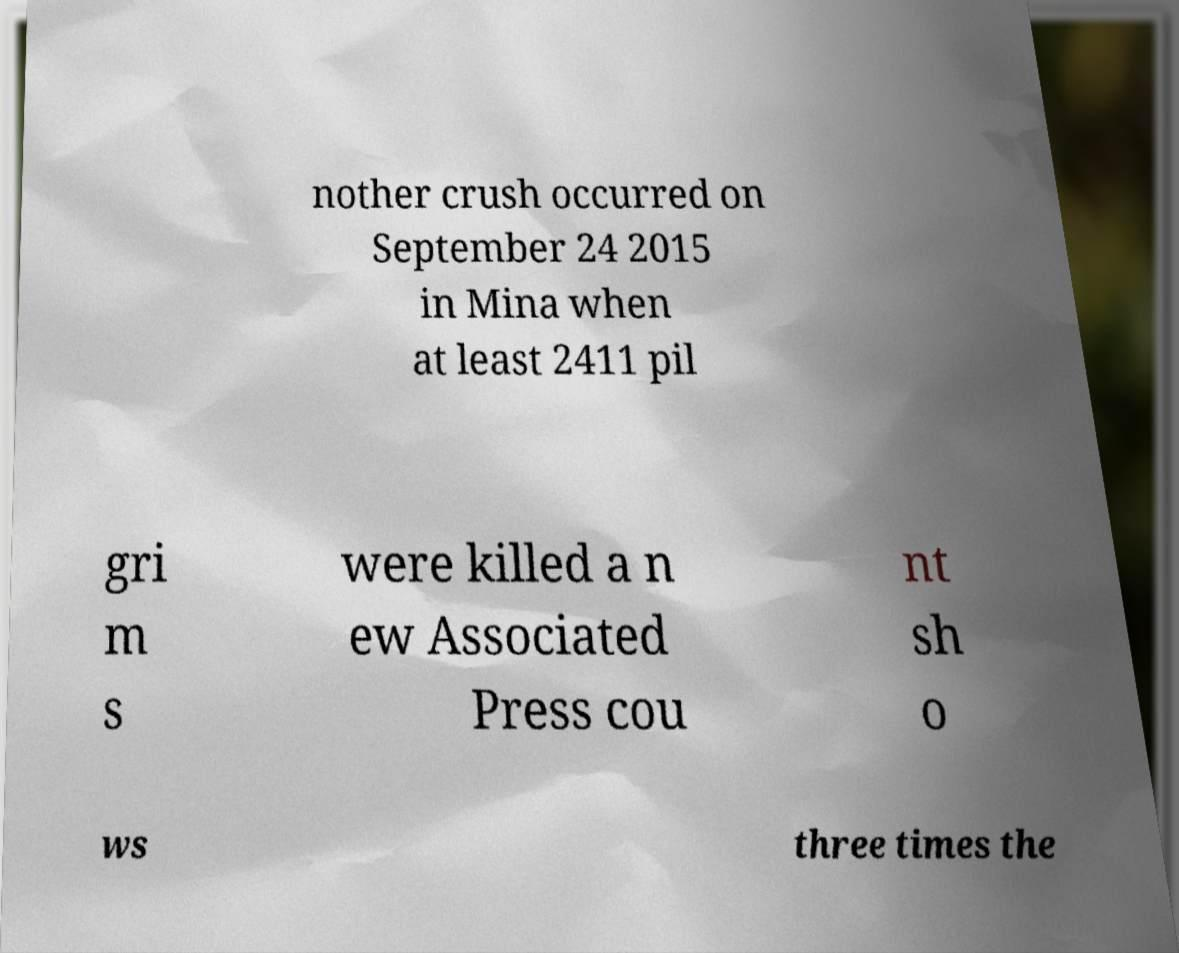Could you extract and type out the text from this image? nother crush occurred on September 24 2015 in Mina when at least 2411 pil gri m s were killed a n ew Associated Press cou nt sh o ws three times the 